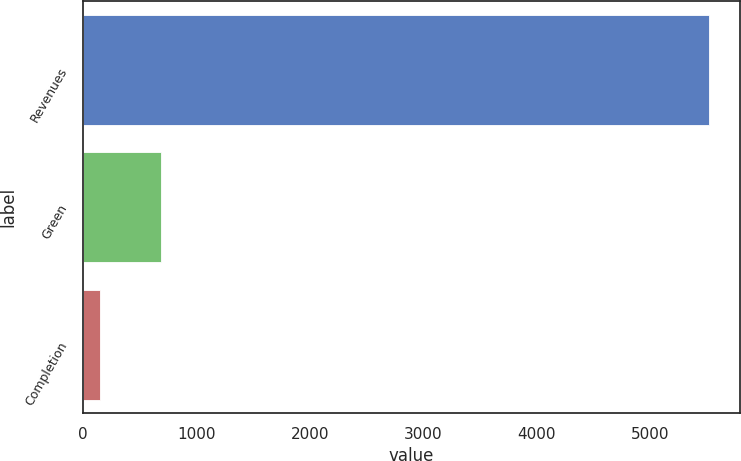Convert chart to OTSL. <chart><loc_0><loc_0><loc_500><loc_500><bar_chart><fcel>Revenues<fcel>Green<fcel>Completion<nl><fcel>5512<fcel>688<fcel>152<nl></chart> 